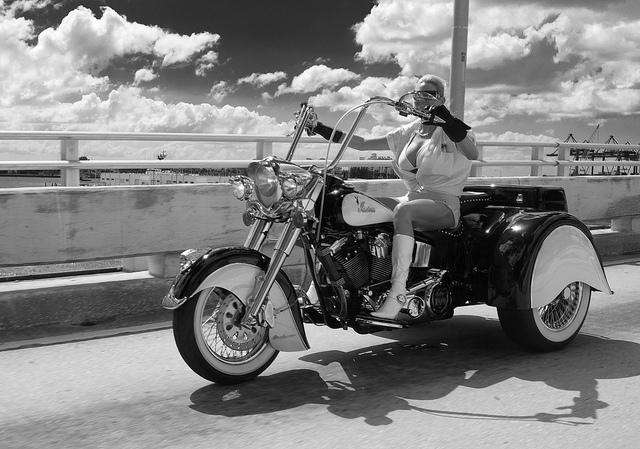How many tires does the bike have?
Answer briefly. 3. Is the person on the motorcycle a man or a woman?
Answer briefly. Woman. Is the bike moving?
Give a very brief answer. Yes. 